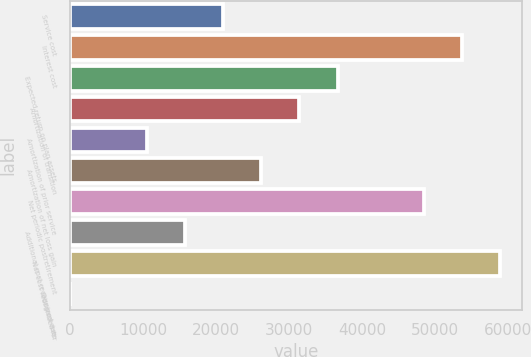<chart> <loc_0><loc_0><loc_500><loc_500><bar_chart><fcel>Service cost<fcel>Interest cost<fcel>Expected return on plan assets<fcel>Amortization of transition<fcel>Amortization of prior service<fcel>Amortization of net loss gain<fcel>Net periodic postretirement<fcel>Additional cost recognized due<fcel>Net cost recognized for<fcel>Discount rate<nl><fcel>20938.6<fcel>53679.1<fcel>36637.8<fcel>31404.7<fcel>10472.4<fcel>26171.7<fcel>48446<fcel>15705.5<fcel>58912.2<fcel>6.25<nl></chart> 